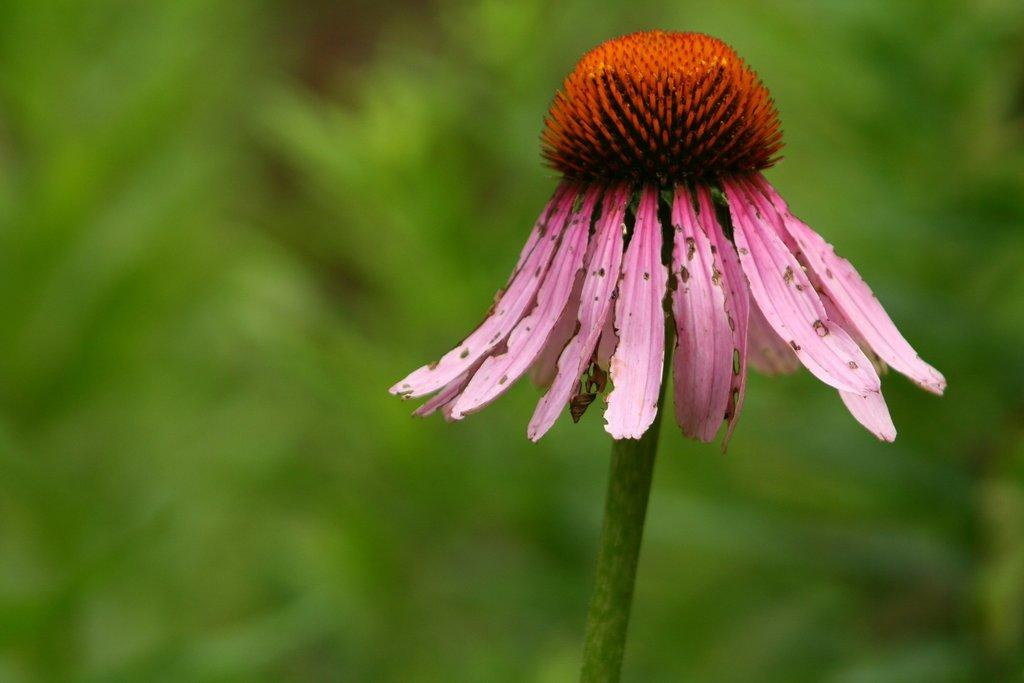What is the main subject of the image? There is a flower in the image. Can you describe the flower in more detail? The flower has a stem. What can be observed about the background of the image? The background of the image is blurred and green. What type of quince can be seen floating in the ink in the image? There is no quince or ink present in the image; it features a flower with a blurred green background. 